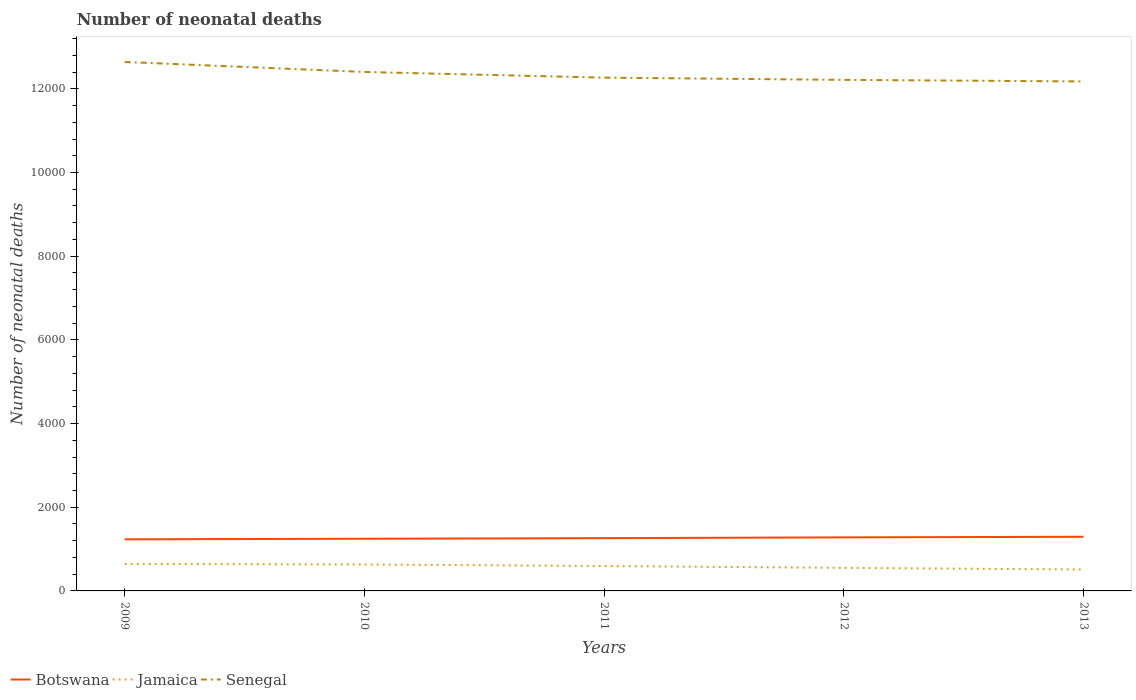Does the line corresponding to Botswana intersect with the line corresponding to Senegal?
Your answer should be compact. No. Is the number of lines equal to the number of legend labels?
Ensure brevity in your answer.  Yes. Across all years, what is the maximum number of neonatal deaths in in Jamaica?
Your answer should be very brief. 512. What is the total number of neonatal deaths in in Botswana in the graph?
Your answer should be very brief. -33. What is the difference between the highest and the second highest number of neonatal deaths in in Botswana?
Provide a short and direct response. 61. How many lines are there?
Keep it short and to the point. 3. What is the difference between two consecutive major ticks on the Y-axis?
Make the answer very short. 2000. Does the graph contain grids?
Provide a succinct answer. No. How many legend labels are there?
Keep it short and to the point. 3. What is the title of the graph?
Your response must be concise. Number of neonatal deaths. Does "Congo (Democratic)" appear as one of the legend labels in the graph?
Provide a short and direct response. No. What is the label or title of the X-axis?
Provide a succinct answer. Years. What is the label or title of the Y-axis?
Your answer should be compact. Number of neonatal deaths. What is the Number of neonatal deaths in Botswana in 2009?
Your response must be concise. 1233. What is the Number of neonatal deaths in Jamaica in 2009?
Your answer should be very brief. 645. What is the Number of neonatal deaths of Senegal in 2009?
Offer a very short reply. 1.26e+04. What is the Number of neonatal deaths in Botswana in 2010?
Provide a succinct answer. 1247. What is the Number of neonatal deaths in Jamaica in 2010?
Provide a succinct answer. 632. What is the Number of neonatal deaths of Senegal in 2010?
Keep it short and to the point. 1.24e+04. What is the Number of neonatal deaths in Botswana in 2011?
Your answer should be very brief. 1261. What is the Number of neonatal deaths of Jamaica in 2011?
Make the answer very short. 595. What is the Number of neonatal deaths in Senegal in 2011?
Offer a terse response. 1.23e+04. What is the Number of neonatal deaths in Botswana in 2012?
Provide a succinct answer. 1280. What is the Number of neonatal deaths of Jamaica in 2012?
Keep it short and to the point. 551. What is the Number of neonatal deaths in Senegal in 2012?
Keep it short and to the point. 1.22e+04. What is the Number of neonatal deaths in Botswana in 2013?
Your answer should be very brief. 1294. What is the Number of neonatal deaths in Jamaica in 2013?
Your response must be concise. 512. What is the Number of neonatal deaths in Senegal in 2013?
Make the answer very short. 1.22e+04. Across all years, what is the maximum Number of neonatal deaths in Botswana?
Give a very brief answer. 1294. Across all years, what is the maximum Number of neonatal deaths of Jamaica?
Offer a terse response. 645. Across all years, what is the maximum Number of neonatal deaths in Senegal?
Provide a short and direct response. 1.26e+04. Across all years, what is the minimum Number of neonatal deaths in Botswana?
Give a very brief answer. 1233. Across all years, what is the minimum Number of neonatal deaths in Jamaica?
Offer a very short reply. 512. Across all years, what is the minimum Number of neonatal deaths in Senegal?
Offer a very short reply. 1.22e+04. What is the total Number of neonatal deaths of Botswana in the graph?
Make the answer very short. 6315. What is the total Number of neonatal deaths in Jamaica in the graph?
Keep it short and to the point. 2935. What is the total Number of neonatal deaths in Senegal in the graph?
Your answer should be compact. 6.17e+04. What is the difference between the Number of neonatal deaths of Jamaica in 2009 and that in 2010?
Ensure brevity in your answer.  13. What is the difference between the Number of neonatal deaths in Senegal in 2009 and that in 2010?
Your response must be concise. 239. What is the difference between the Number of neonatal deaths in Jamaica in 2009 and that in 2011?
Offer a very short reply. 50. What is the difference between the Number of neonatal deaths of Senegal in 2009 and that in 2011?
Keep it short and to the point. 375. What is the difference between the Number of neonatal deaths of Botswana in 2009 and that in 2012?
Provide a succinct answer. -47. What is the difference between the Number of neonatal deaths in Jamaica in 2009 and that in 2012?
Provide a short and direct response. 94. What is the difference between the Number of neonatal deaths in Senegal in 2009 and that in 2012?
Provide a short and direct response. 428. What is the difference between the Number of neonatal deaths of Botswana in 2009 and that in 2013?
Make the answer very short. -61. What is the difference between the Number of neonatal deaths in Jamaica in 2009 and that in 2013?
Give a very brief answer. 133. What is the difference between the Number of neonatal deaths in Senegal in 2009 and that in 2013?
Offer a very short reply. 466. What is the difference between the Number of neonatal deaths of Botswana in 2010 and that in 2011?
Your response must be concise. -14. What is the difference between the Number of neonatal deaths in Jamaica in 2010 and that in 2011?
Your response must be concise. 37. What is the difference between the Number of neonatal deaths in Senegal in 2010 and that in 2011?
Your answer should be very brief. 136. What is the difference between the Number of neonatal deaths of Botswana in 2010 and that in 2012?
Offer a very short reply. -33. What is the difference between the Number of neonatal deaths in Jamaica in 2010 and that in 2012?
Give a very brief answer. 81. What is the difference between the Number of neonatal deaths in Senegal in 2010 and that in 2012?
Offer a very short reply. 189. What is the difference between the Number of neonatal deaths of Botswana in 2010 and that in 2013?
Offer a very short reply. -47. What is the difference between the Number of neonatal deaths in Jamaica in 2010 and that in 2013?
Your answer should be compact. 120. What is the difference between the Number of neonatal deaths of Senegal in 2010 and that in 2013?
Your answer should be very brief. 227. What is the difference between the Number of neonatal deaths of Botswana in 2011 and that in 2012?
Provide a succinct answer. -19. What is the difference between the Number of neonatal deaths of Jamaica in 2011 and that in 2012?
Offer a terse response. 44. What is the difference between the Number of neonatal deaths of Senegal in 2011 and that in 2012?
Give a very brief answer. 53. What is the difference between the Number of neonatal deaths in Botswana in 2011 and that in 2013?
Your answer should be very brief. -33. What is the difference between the Number of neonatal deaths in Jamaica in 2011 and that in 2013?
Your answer should be very brief. 83. What is the difference between the Number of neonatal deaths in Senegal in 2011 and that in 2013?
Provide a succinct answer. 91. What is the difference between the Number of neonatal deaths of Jamaica in 2012 and that in 2013?
Give a very brief answer. 39. What is the difference between the Number of neonatal deaths in Botswana in 2009 and the Number of neonatal deaths in Jamaica in 2010?
Give a very brief answer. 601. What is the difference between the Number of neonatal deaths in Botswana in 2009 and the Number of neonatal deaths in Senegal in 2010?
Provide a short and direct response. -1.12e+04. What is the difference between the Number of neonatal deaths in Jamaica in 2009 and the Number of neonatal deaths in Senegal in 2010?
Keep it short and to the point. -1.18e+04. What is the difference between the Number of neonatal deaths in Botswana in 2009 and the Number of neonatal deaths in Jamaica in 2011?
Your answer should be very brief. 638. What is the difference between the Number of neonatal deaths of Botswana in 2009 and the Number of neonatal deaths of Senegal in 2011?
Provide a short and direct response. -1.10e+04. What is the difference between the Number of neonatal deaths in Jamaica in 2009 and the Number of neonatal deaths in Senegal in 2011?
Your response must be concise. -1.16e+04. What is the difference between the Number of neonatal deaths of Botswana in 2009 and the Number of neonatal deaths of Jamaica in 2012?
Keep it short and to the point. 682. What is the difference between the Number of neonatal deaths in Botswana in 2009 and the Number of neonatal deaths in Senegal in 2012?
Offer a terse response. -1.10e+04. What is the difference between the Number of neonatal deaths in Jamaica in 2009 and the Number of neonatal deaths in Senegal in 2012?
Offer a terse response. -1.16e+04. What is the difference between the Number of neonatal deaths of Botswana in 2009 and the Number of neonatal deaths of Jamaica in 2013?
Provide a short and direct response. 721. What is the difference between the Number of neonatal deaths in Botswana in 2009 and the Number of neonatal deaths in Senegal in 2013?
Offer a terse response. -1.09e+04. What is the difference between the Number of neonatal deaths of Jamaica in 2009 and the Number of neonatal deaths of Senegal in 2013?
Offer a terse response. -1.15e+04. What is the difference between the Number of neonatal deaths in Botswana in 2010 and the Number of neonatal deaths in Jamaica in 2011?
Ensure brevity in your answer.  652. What is the difference between the Number of neonatal deaths in Botswana in 2010 and the Number of neonatal deaths in Senegal in 2011?
Make the answer very short. -1.10e+04. What is the difference between the Number of neonatal deaths in Jamaica in 2010 and the Number of neonatal deaths in Senegal in 2011?
Your answer should be very brief. -1.16e+04. What is the difference between the Number of neonatal deaths of Botswana in 2010 and the Number of neonatal deaths of Jamaica in 2012?
Provide a succinct answer. 696. What is the difference between the Number of neonatal deaths of Botswana in 2010 and the Number of neonatal deaths of Senegal in 2012?
Make the answer very short. -1.10e+04. What is the difference between the Number of neonatal deaths of Jamaica in 2010 and the Number of neonatal deaths of Senegal in 2012?
Provide a succinct answer. -1.16e+04. What is the difference between the Number of neonatal deaths in Botswana in 2010 and the Number of neonatal deaths in Jamaica in 2013?
Your answer should be compact. 735. What is the difference between the Number of neonatal deaths in Botswana in 2010 and the Number of neonatal deaths in Senegal in 2013?
Your answer should be very brief. -1.09e+04. What is the difference between the Number of neonatal deaths in Jamaica in 2010 and the Number of neonatal deaths in Senegal in 2013?
Make the answer very short. -1.15e+04. What is the difference between the Number of neonatal deaths of Botswana in 2011 and the Number of neonatal deaths of Jamaica in 2012?
Provide a succinct answer. 710. What is the difference between the Number of neonatal deaths of Botswana in 2011 and the Number of neonatal deaths of Senegal in 2012?
Your response must be concise. -1.10e+04. What is the difference between the Number of neonatal deaths in Jamaica in 2011 and the Number of neonatal deaths in Senegal in 2012?
Give a very brief answer. -1.16e+04. What is the difference between the Number of neonatal deaths of Botswana in 2011 and the Number of neonatal deaths of Jamaica in 2013?
Your answer should be very brief. 749. What is the difference between the Number of neonatal deaths in Botswana in 2011 and the Number of neonatal deaths in Senegal in 2013?
Your response must be concise. -1.09e+04. What is the difference between the Number of neonatal deaths in Jamaica in 2011 and the Number of neonatal deaths in Senegal in 2013?
Provide a short and direct response. -1.16e+04. What is the difference between the Number of neonatal deaths of Botswana in 2012 and the Number of neonatal deaths of Jamaica in 2013?
Provide a succinct answer. 768. What is the difference between the Number of neonatal deaths of Botswana in 2012 and the Number of neonatal deaths of Senegal in 2013?
Give a very brief answer. -1.09e+04. What is the difference between the Number of neonatal deaths in Jamaica in 2012 and the Number of neonatal deaths in Senegal in 2013?
Your answer should be compact. -1.16e+04. What is the average Number of neonatal deaths in Botswana per year?
Keep it short and to the point. 1263. What is the average Number of neonatal deaths in Jamaica per year?
Ensure brevity in your answer.  587. What is the average Number of neonatal deaths in Senegal per year?
Ensure brevity in your answer.  1.23e+04. In the year 2009, what is the difference between the Number of neonatal deaths in Botswana and Number of neonatal deaths in Jamaica?
Your answer should be compact. 588. In the year 2009, what is the difference between the Number of neonatal deaths in Botswana and Number of neonatal deaths in Senegal?
Keep it short and to the point. -1.14e+04. In the year 2009, what is the difference between the Number of neonatal deaths in Jamaica and Number of neonatal deaths in Senegal?
Ensure brevity in your answer.  -1.20e+04. In the year 2010, what is the difference between the Number of neonatal deaths in Botswana and Number of neonatal deaths in Jamaica?
Ensure brevity in your answer.  615. In the year 2010, what is the difference between the Number of neonatal deaths of Botswana and Number of neonatal deaths of Senegal?
Ensure brevity in your answer.  -1.12e+04. In the year 2010, what is the difference between the Number of neonatal deaths in Jamaica and Number of neonatal deaths in Senegal?
Ensure brevity in your answer.  -1.18e+04. In the year 2011, what is the difference between the Number of neonatal deaths in Botswana and Number of neonatal deaths in Jamaica?
Give a very brief answer. 666. In the year 2011, what is the difference between the Number of neonatal deaths of Botswana and Number of neonatal deaths of Senegal?
Provide a succinct answer. -1.10e+04. In the year 2011, what is the difference between the Number of neonatal deaths in Jamaica and Number of neonatal deaths in Senegal?
Ensure brevity in your answer.  -1.17e+04. In the year 2012, what is the difference between the Number of neonatal deaths in Botswana and Number of neonatal deaths in Jamaica?
Your answer should be compact. 729. In the year 2012, what is the difference between the Number of neonatal deaths in Botswana and Number of neonatal deaths in Senegal?
Make the answer very short. -1.09e+04. In the year 2012, what is the difference between the Number of neonatal deaths of Jamaica and Number of neonatal deaths of Senegal?
Offer a terse response. -1.17e+04. In the year 2013, what is the difference between the Number of neonatal deaths of Botswana and Number of neonatal deaths of Jamaica?
Offer a very short reply. 782. In the year 2013, what is the difference between the Number of neonatal deaths of Botswana and Number of neonatal deaths of Senegal?
Give a very brief answer. -1.09e+04. In the year 2013, what is the difference between the Number of neonatal deaths in Jamaica and Number of neonatal deaths in Senegal?
Ensure brevity in your answer.  -1.17e+04. What is the ratio of the Number of neonatal deaths in Botswana in 2009 to that in 2010?
Provide a short and direct response. 0.99. What is the ratio of the Number of neonatal deaths of Jamaica in 2009 to that in 2010?
Give a very brief answer. 1.02. What is the ratio of the Number of neonatal deaths in Senegal in 2009 to that in 2010?
Keep it short and to the point. 1.02. What is the ratio of the Number of neonatal deaths of Botswana in 2009 to that in 2011?
Your answer should be compact. 0.98. What is the ratio of the Number of neonatal deaths in Jamaica in 2009 to that in 2011?
Your answer should be compact. 1.08. What is the ratio of the Number of neonatal deaths of Senegal in 2009 to that in 2011?
Ensure brevity in your answer.  1.03. What is the ratio of the Number of neonatal deaths of Botswana in 2009 to that in 2012?
Your answer should be compact. 0.96. What is the ratio of the Number of neonatal deaths in Jamaica in 2009 to that in 2012?
Offer a terse response. 1.17. What is the ratio of the Number of neonatal deaths of Senegal in 2009 to that in 2012?
Your answer should be compact. 1.03. What is the ratio of the Number of neonatal deaths of Botswana in 2009 to that in 2013?
Ensure brevity in your answer.  0.95. What is the ratio of the Number of neonatal deaths of Jamaica in 2009 to that in 2013?
Offer a very short reply. 1.26. What is the ratio of the Number of neonatal deaths of Senegal in 2009 to that in 2013?
Give a very brief answer. 1.04. What is the ratio of the Number of neonatal deaths in Botswana in 2010 to that in 2011?
Offer a terse response. 0.99. What is the ratio of the Number of neonatal deaths in Jamaica in 2010 to that in 2011?
Your answer should be very brief. 1.06. What is the ratio of the Number of neonatal deaths in Senegal in 2010 to that in 2011?
Offer a terse response. 1.01. What is the ratio of the Number of neonatal deaths of Botswana in 2010 to that in 2012?
Give a very brief answer. 0.97. What is the ratio of the Number of neonatal deaths in Jamaica in 2010 to that in 2012?
Ensure brevity in your answer.  1.15. What is the ratio of the Number of neonatal deaths of Senegal in 2010 to that in 2012?
Make the answer very short. 1.02. What is the ratio of the Number of neonatal deaths of Botswana in 2010 to that in 2013?
Give a very brief answer. 0.96. What is the ratio of the Number of neonatal deaths of Jamaica in 2010 to that in 2013?
Keep it short and to the point. 1.23. What is the ratio of the Number of neonatal deaths of Senegal in 2010 to that in 2013?
Offer a terse response. 1.02. What is the ratio of the Number of neonatal deaths in Botswana in 2011 to that in 2012?
Make the answer very short. 0.99. What is the ratio of the Number of neonatal deaths of Jamaica in 2011 to that in 2012?
Provide a succinct answer. 1.08. What is the ratio of the Number of neonatal deaths in Botswana in 2011 to that in 2013?
Provide a succinct answer. 0.97. What is the ratio of the Number of neonatal deaths in Jamaica in 2011 to that in 2013?
Your answer should be compact. 1.16. What is the ratio of the Number of neonatal deaths in Senegal in 2011 to that in 2013?
Your answer should be compact. 1.01. What is the ratio of the Number of neonatal deaths in Jamaica in 2012 to that in 2013?
Provide a succinct answer. 1.08. What is the difference between the highest and the second highest Number of neonatal deaths in Senegal?
Offer a terse response. 239. What is the difference between the highest and the lowest Number of neonatal deaths in Jamaica?
Ensure brevity in your answer.  133. What is the difference between the highest and the lowest Number of neonatal deaths of Senegal?
Offer a very short reply. 466. 